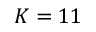<formula> <loc_0><loc_0><loc_500><loc_500>K = 1 1</formula> 